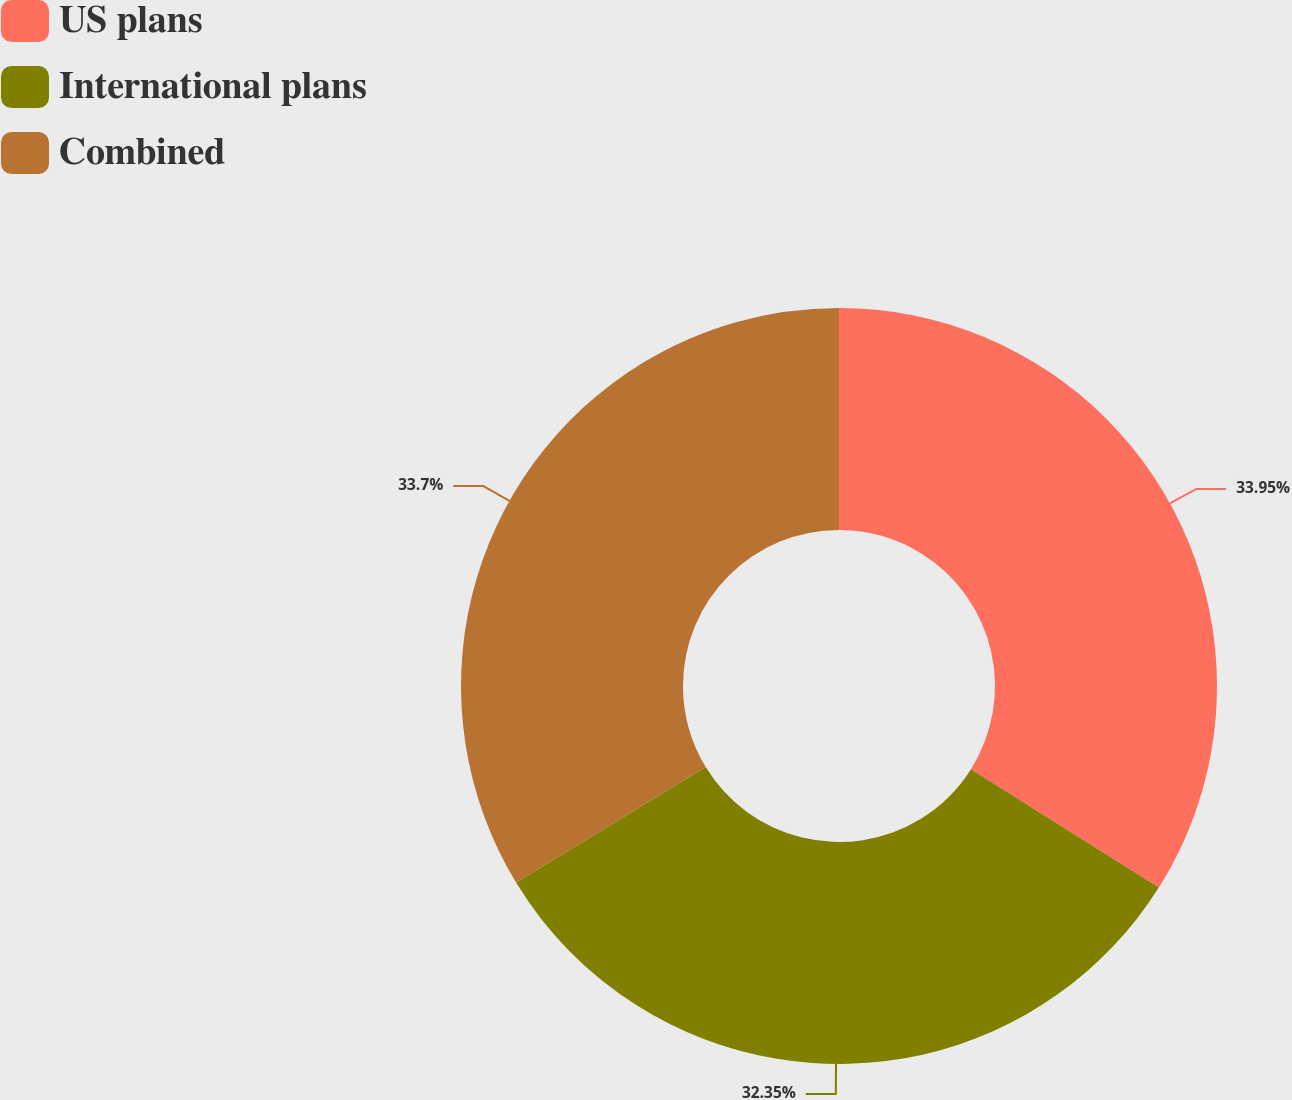Convert chart. <chart><loc_0><loc_0><loc_500><loc_500><pie_chart><fcel>US plans<fcel>International plans<fcel>Combined<nl><fcel>33.95%<fcel>32.35%<fcel>33.7%<nl></chart> 